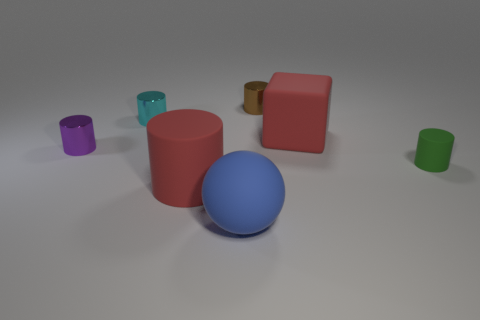What number of other things are the same color as the large matte cylinder?
Keep it short and to the point. 1. Is the number of large red spheres greater than the number of tiny purple metallic cylinders?
Your answer should be compact. No. What color is the large rubber thing behind the tiny green rubber cylinder?
Offer a very short reply. Red. What is the size of the matte thing that is both on the right side of the brown cylinder and on the left side of the green cylinder?
Give a very brief answer. Large. How many shiny cylinders are the same size as the cyan thing?
Provide a short and direct response. 2. What material is the tiny green thing that is the same shape as the small cyan thing?
Offer a very short reply. Rubber. Is the blue matte thing the same shape as the small cyan thing?
Your response must be concise. No. There is a brown cylinder; what number of purple cylinders are behind it?
Give a very brief answer. 0. The red matte object on the left side of the rubber ball in front of the cyan object is what shape?
Ensure brevity in your answer.  Cylinder. The cyan thing that is the same material as the brown cylinder is what shape?
Give a very brief answer. Cylinder. 